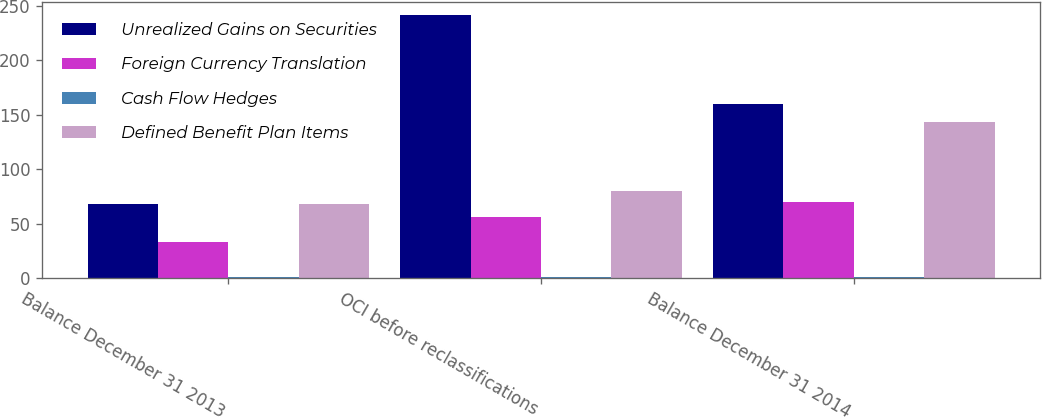Convert chart. <chart><loc_0><loc_0><loc_500><loc_500><stacked_bar_chart><ecel><fcel>Balance December 31 2013<fcel>OCI before reclassifications<fcel>Balance December 31 2014<nl><fcel>Unrealized Gains on Securities<fcel>67.6<fcel>241.5<fcel>159.6<nl><fcel>Foreign Currency Translation<fcel>33.1<fcel>55.9<fcel>70.1<nl><fcel>Cash Flow Hedges<fcel>0.5<fcel>0.5<fcel>0.4<nl><fcel>Defined Benefit Plan Items<fcel>67.6<fcel>80<fcel>143.4<nl></chart> 